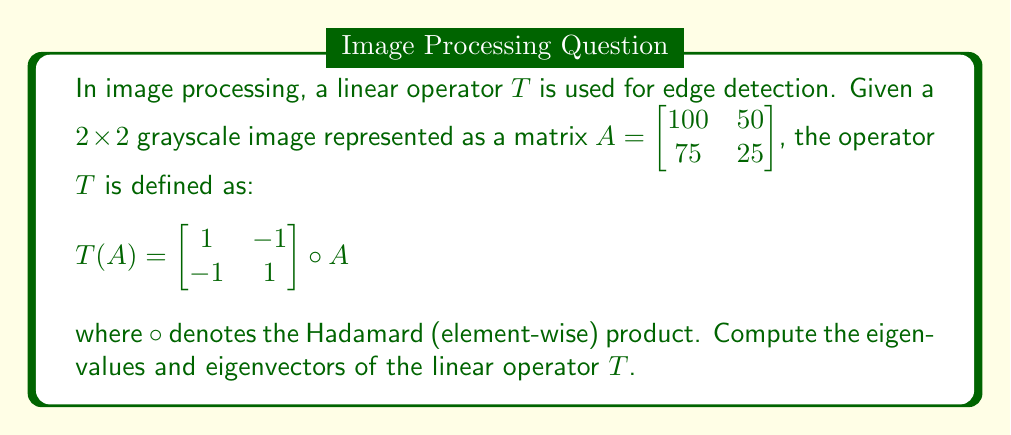Solve this math problem. To find the eigenvalues and eigenvectors of the linear operator $T$, we need to follow these steps:

1) First, we need to express $T$ as a matrix. Let's apply $T$ to the standard basis vectors:

   $T(\begin{bmatrix} 1 & 0 \\ 0 & 0 \end{bmatrix}) = \begin{bmatrix} 1 & 0 \\ 0 & 0 \end{bmatrix}$
   $T(\begin{bmatrix} 0 & 1 \\ 0 & 0 \end{bmatrix}) = \begin{bmatrix} 0 & -1 \\ 0 & 0 \end{bmatrix}$
   $T(\begin{bmatrix} 0 & 0 \\ 1 & 0 \end{bmatrix}) = \begin{bmatrix} 0 & 0 \\ -1 & 0 \end{bmatrix}$
   $T(\begin{bmatrix} 0 & 0 \\ 0 & 1 \end{bmatrix}) = \begin{bmatrix} 0 & 0 \\ 0 & 1 \end{bmatrix}$

2) From this, we can express $T$ as a $4\times4$ matrix:

   $T = \begin{bmatrix} 1 & 0 & 0 & 0 \\ 0 & -1 & 0 & 0 \\ 0 & 0 & -1 & 0 \\ 0 & 0 & 0 & 1 \end{bmatrix}$

3) To find the eigenvalues, we solve the characteristic equation:

   $\det(T - \lambda I) = 0$

   $(1-\lambda)(-1-\lambda)(-1-\lambda)(1-\lambda) = 0$

4) Solving this equation, we get the eigenvalues:
   $\lambda_1 = 1$ (with multiplicity 2)
   $\lambda_2 = -1$ (with multiplicity 2)

5) For eigenvectors, we solve $(T - \lambda I)v = 0$ for each eigenvalue:

   For $\lambda = 1$:
   $(T - I)v = 0$ gives us $v_1 = (1,0,0,0)^T$ and $v_2 = (0,0,0,1)^T$

   For $\lambda = -1$:
   $(T + I)v = 0$ gives us $v_3 = (0,1,0,0)^T$ and $v_4 = (0,0,1,0)^T$

6) These eigenvectors correspond to the following $2\times2$ matrices:

   $v_1 \rightarrow \begin{bmatrix} 1 & 0 \\ 0 & 0 \end{bmatrix}$
   $v_2 \rightarrow \begin{bmatrix} 0 & 0 \\ 0 & 1 \end{bmatrix}$
   $v_3 \rightarrow \begin{bmatrix} 0 & 1 \\ 0 & 0 \end{bmatrix}$
   $v_4 \rightarrow \begin{bmatrix} 0 & 0 \\ 1 & 0 \end{bmatrix}$
Answer: Eigenvalues: $\lambda_1 = 1$ (multiplicity 2), $\lambda_2 = -1$ (multiplicity 2)

Eigenvectors (as $2\times2$ matrices):
$\begin{bmatrix} 1 & 0 \\ 0 & 0 \end{bmatrix}$ and $\begin{bmatrix} 0 & 0 \\ 0 & 1 \end{bmatrix}$ for $\lambda_1 = 1$
$\begin{bmatrix} 0 & 1 \\ 0 & 0 \end{bmatrix}$ and $\begin{bmatrix} 0 & 0 \\ 1 & 0 \end{bmatrix}$ for $\lambda_2 = -1$ 